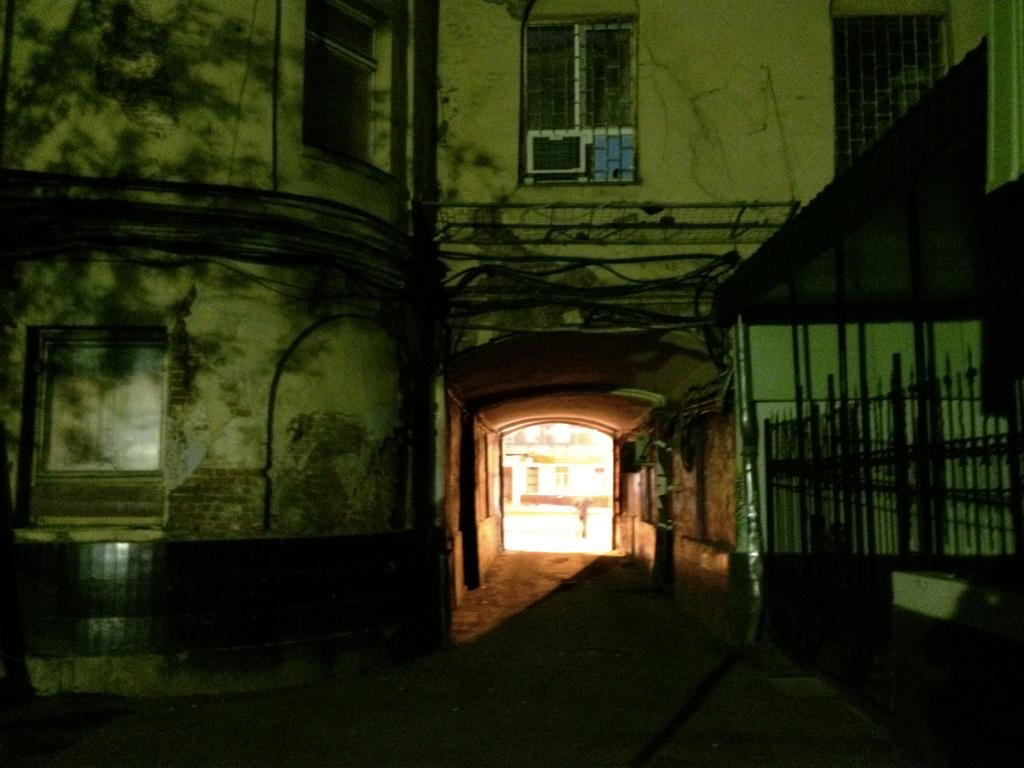What type of structure is present in the image? There is a building in the picture. What are some features of the building? The building has windows and iron grilles. Is there any equipment visible in the image? Yes, there is an air conditioner in the picture. What type of bait is being used to catch fish in the picture? There is no mention of fish or bait in the image; it features a building with windows, iron grilles, and an air conditioner. 